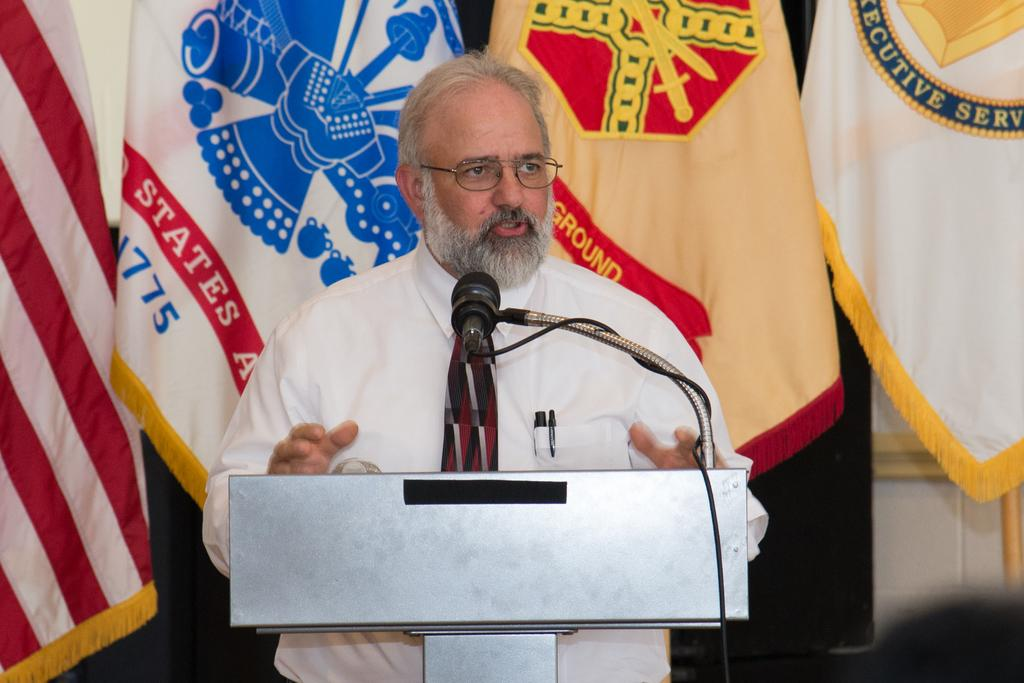<image>
Summarize the visual content of the image. A man speaks at a podium in front of a flag with the word "ground" on it. 